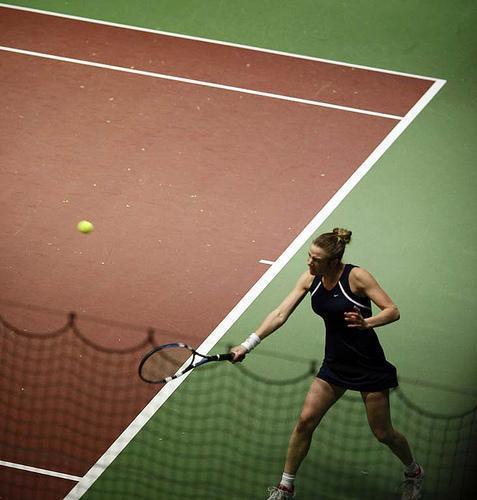How many train cars are on the right of the man ?
Give a very brief answer. 0. 